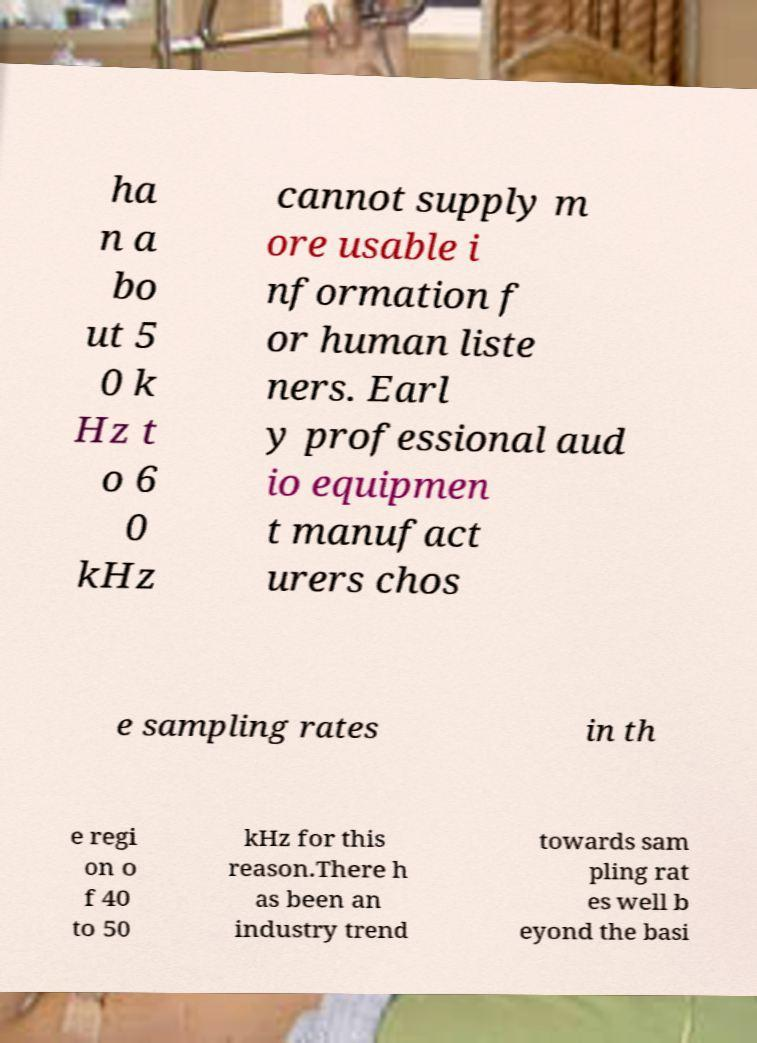For documentation purposes, I need the text within this image transcribed. Could you provide that? ha n a bo ut 5 0 k Hz t o 6 0 kHz cannot supply m ore usable i nformation f or human liste ners. Earl y professional aud io equipmen t manufact urers chos e sampling rates in th e regi on o f 40 to 50 kHz for this reason.There h as been an industry trend towards sam pling rat es well b eyond the basi 